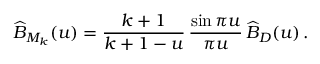Convert formula to latex. <formula><loc_0><loc_0><loc_500><loc_500>\widehat { B } _ { M _ { k } } ( u ) = \frac { k + 1 } { k + 1 - u } \, \frac { \sin \pi u } { \pi u } \, \widehat { B } _ { D } ( u ) \, .</formula> 